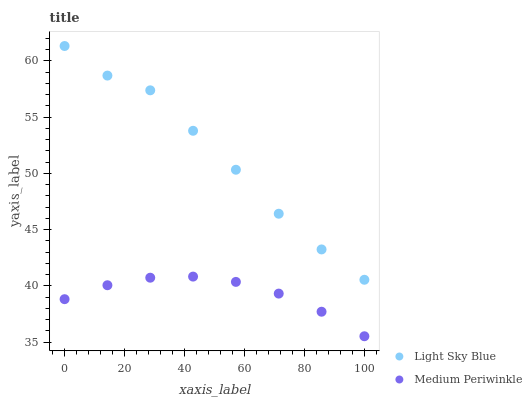Does Medium Periwinkle have the minimum area under the curve?
Answer yes or no. Yes. Does Light Sky Blue have the maximum area under the curve?
Answer yes or no. Yes. Does Medium Periwinkle have the maximum area under the curve?
Answer yes or no. No. Is Medium Periwinkle the smoothest?
Answer yes or no. Yes. Is Light Sky Blue the roughest?
Answer yes or no. Yes. Is Medium Periwinkle the roughest?
Answer yes or no. No. Does Medium Periwinkle have the lowest value?
Answer yes or no. Yes. Does Light Sky Blue have the highest value?
Answer yes or no. Yes. Does Medium Periwinkle have the highest value?
Answer yes or no. No. Is Medium Periwinkle less than Light Sky Blue?
Answer yes or no. Yes. Is Light Sky Blue greater than Medium Periwinkle?
Answer yes or no. Yes. Does Medium Periwinkle intersect Light Sky Blue?
Answer yes or no. No. 